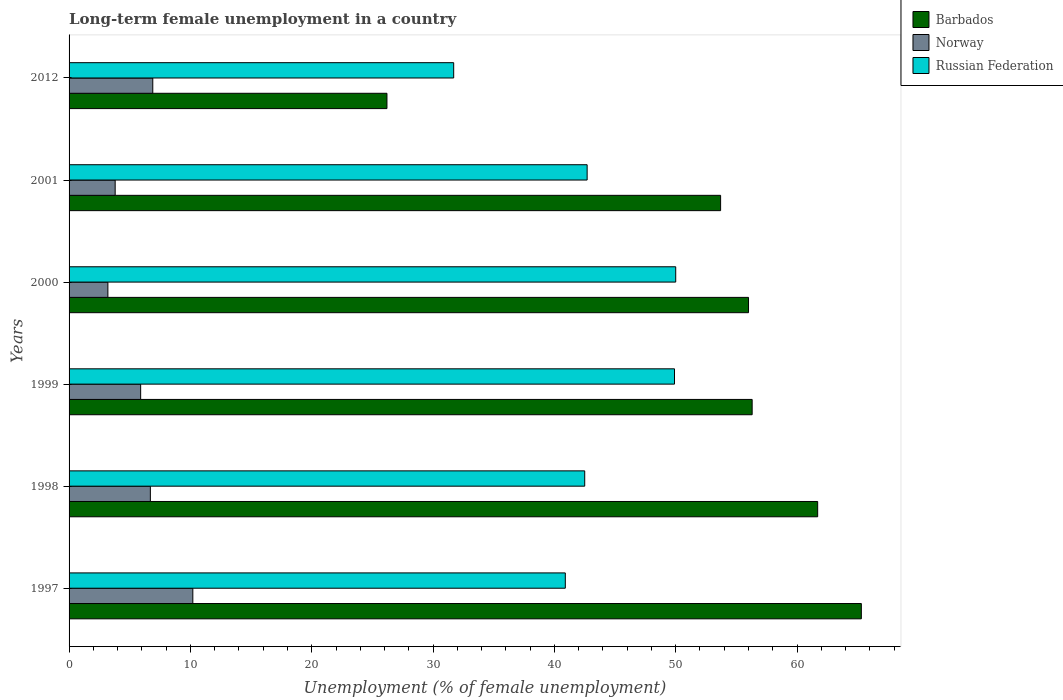How many groups of bars are there?
Provide a short and direct response. 6. How many bars are there on the 3rd tick from the top?
Offer a terse response. 3. In how many cases, is the number of bars for a given year not equal to the number of legend labels?
Provide a succinct answer. 0. Across all years, what is the maximum percentage of long-term unemployed female population in Russian Federation?
Your answer should be compact. 50. Across all years, what is the minimum percentage of long-term unemployed female population in Norway?
Ensure brevity in your answer.  3.2. What is the total percentage of long-term unemployed female population in Russian Federation in the graph?
Provide a succinct answer. 257.7. What is the difference between the percentage of long-term unemployed female population in Norway in 1998 and that in 2001?
Offer a very short reply. 2.9. What is the difference between the percentage of long-term unemployed female population in Russian Federation in 2000 and the percentage of long-term unemployed female population in Barbados in 1998?
Ensure brevity in your answer.  -11.7. What is the average percentage of long-term unemployed female population in Russian Federation per year?
Your answer should be very brief. 42.95. In the year 1997, what is the difference between the percentage of long-term unemployed female population in Barbados and percentage of long-term unemployed female population in Norway?
Ensure brevity in your answer.  55.1. In how many years, is the percentage of long-term unemployed female population in Barbados greater than 58 %?
Ensure brevity in your answer.  2. What is the ratio of the percentage of long-term unemployed female population in Barbados in 1999 to that in 2012?
Make the answer very short. 2.15. What is the difference between the highest and the second highest percentage of long-term unemployed female population in Norway?
Offer a very short reply. 3.3. What is the difference between the highest and the lowest percentage of long-term unemployed female population in Norway?
Your response must be concise. 7. In how many years, is the percentage of long-term unemployed female population in Norway greater than the average percentage of long-term unemployed female population in Norway taken over all years?
Your response must be concise. 3. What does the 2nd bar from the top in 2012 represents?
Give a very brief answer. Norway. Is it the case that in every year, the sum of the percentage of long-term unemployed female population in Russian Federation and percentage of long-term unemployed female population in Barbados is greater than the percentage of long-term unemployed female population in Norway?
Your answer should be compact. Yes. Are all the bars in the graph horizontal?
Provide a short and direct response. Yes. Does the graph contain any zero values?
Your answer should be very brief. No. Where does the legend appear in the graph?
Your answer should be compact. Top right. How many legend labels are there?
Offer a very short reply. 3. How are the legend labels stacked?
Your answer should be very brief. Vertical. What is the title of the graph?
Your response must be concise. Long-term female unemployment in a country. What is the label or title of the X-axis?
Provide a short and direct response. Unemployment (% of female unemployment). What is the Unemployment (% of female unemployment) in Barbados in 1997?
Offer a very short reply. 65.3. What is the Unemployment (% of female unemployment) in Norway in 1997?
Your response must be concise. 10.2. What is the Unemployment (% of female unemployment) of Russian Federation in 1997?
Your answer should be compact. 40.9. What is the Unemployment (% of female unemployment) of Barbados in 1998?
Give a very brief answer. 61.7. What is the Unemployment (% of female unemployment) of Norway in 1998?
Offer a terse response. 6.7. What is the Unemployment (% of female unemployment) in Russian Federation in 1998?
Offer a terse response. 42.5. What is the Unemployment (% of female unemployment) of Barbados in 1999?
Your answer should be very brief. 56.3. What is the Unemployment (% of female unemployment) in Norway in 1999?
Provide a succinct answer. 5.9. What is the Unemployment (% of female unemployment) in Russian Federation in 1999?
Give a very brief answer. 49.9. What is the Unemployment (% of female unemployment) of Barbados in 2000?
Offer a very short reply. 56. What is the Unemployment (% of female unemployment) in Norway in 2000?
Your answer should be very brief. 3.2. What is the Unemployment (% of female unemployment) of Russian Federation in 2000?
Give a very brief answer. 50. What is the Unemployment (% of female unemployment) in Barbados in 2001?
Offer a very short reply. 53.7. What is the Unemployment (% of female unemployment) of Norway in 2001?
Your answer should be compact. 3.8. What is the Unemployment (% of female unemployment) in Russian Federation in 2001?
Keep it short and to the point. 42.7. What is the Unemployment (% of female unemployment) of Barbados in 2012?
Your response must be concise. 26.2. What is the Unemployment (% of female unemployment) of Norway in 2012?
Keep it short and to the point. 6.9. What is the Unemployment (% of female unemployment) of Russian Federation in 2012?
Offer a terse response. 31.7. Across all years, what is the maximum Unemployment (% of female unemployment) of Barbados?
Keep it short and to the point. 65.3. Across all years, what is the maximum Unemployment (% of female unemployment) of Norway?
Make the answer very short. 10.2. Across all years, what is the maximum Unemployment (% of female unemployment) of Russian Federation?
Make the answer very short. 50. Across all years, what is the minimum Unemployment (% of female unemployment) of Barbados?
Provide a short and direct response. 26.2. Across all years, what is the minimum Unemployment (% of female unemployment) in Norway?
Your answer should be compact. 3.2. Across all years, what is the minimum Unemployment (% of female unemployment) of Russian Federation?
Give a very brief answer. 31.7. What is the total Unemployment (% of female unemployment) of Barbados in the graph?
Ensure brevity in your answer.  319.2. What is the total Unemployment (% of female unemployment) in Norway in the graph?
Give a very brief answer. 36.7. What is the total Unemployment (% of female unemployment) in Russian Federation in the graph?
Offer a very short reply. 257.7. What is the difference between the Unemployment (% of female unemployment) of Norway in 1997 and that in 1998?
Provide a short and direct response. 3.5. What is the difference between the Unemployment (% of female unemployment) of Russian Federation in 1997 and that in 1998?
Your answer should be compact. -1.6. What is the difference between the Unemployment (% of female unemployment) of Norway in 1997 and that in 1999?
Offer a very short reply. 4.3. What is the difference between the Unemployment (% of female unemployment) of Barbados in 1997 and that in 2000?
Offer a terse response. 9.3. What is the difference between the Unemployment (% of female unemployment) of Norway in 1997 and that in 2000?
Your answer should be compact. 7. What is the difference between the Unemployment (% of female unemployment) of Russian Federation in 1997 and that in 2001?
Offer a very short reply. -1.8. What is the difference between the Unemployment (% of female unemployment) in Barbados in 1997 and that in 2012?
Ensure brevity in your answer.  39.1. What is the difference between the Unemployment (% of female unemployment) in Russian Federation in 1997 and that in 2012?
Your answer should be very brief. 9.2. What is the difference between the Unemployment (% of female unemployment) of Barbados in 1998 and that in 1999?
Provide a short and direct response. 5.4. What is the difference between the Unemployment (% of female unemployment) in Russian Federation in 1998 and that in 1999?
Your response must be concise. -7.4. What is the difference between the Unemployment (% of female unemployment) of Barbados in 1998 and that in 2000?
Your answer should be very brief. 5.7. What is the difference between the Unemployment (% of female unemployment) of Barbados in 1998 and that in 2012?
Your answer should be very brief. 35.5. What is the difference between the Unemployment (% of female unemployment) in Norway in 1999 and that in 2000?
Make the answer very short. 2.7. What is the difference between the Unemployment (% of female unemployment) of Russian Federation in 1999 and that in 2000?
Give a very brief answer. -0.1. What is the difference between the Unemployment (% of female unemployment) in Norway in 1999 and that in 2001?
Your answer should be very brief. 2.1. What is the difference between the Unemployment (% of female unemployment) of Russian Federation in 1999 and that in 2001?
Provide a short and direct response. 7.2. What is the difference between the Unemployment (% of female unemployment) of Barbados in 1999 and that in 2012?
Offer a terse response. 30.1. What is the difference between the Unemployment (% of female unemployment) of Norway in 1999 and that in 2012?
Keep it short and to the point. -1. What is the difference between the Unemployment (% of female unemployment) of Russian Federation in 1999 and that in 2012?
Offer a terse response. 18.2. What is the difference between the Unemployment (% of female unemployment) of Russian Federation in 2000 and that in 2001?
Your answer should be compact. 7.3. What is the difference between the Unemployment (% of female unemployment) in Barbados in 2000 and that in 2012?
Provide a succinct answer. 29.8. What is the difference between the Unemployment (% of female unemployment) of Norway in 2000 and that in 2012?
Your answer should be very brief. -3.7. What is the difference between the Unemployment (% of female unemployment) of Russian Federation in 2000 and that in 2012?
Offer a terse response. 18.3. What is the difference between the Unemployment (% of female unemployment) of Barbados in 1997 and the Unemployment (% of female unemployment) of Norway in 1998?
Provide a short and direct response. 58.6. What is the difference between the Unemployment (% of female unemployment) of Barbados in 1997 and the Unemployment (% of female unemployment) of Russian Federation in 1998?
Keep it short and to the point. 22.8. What is the difference between the Unemployment (% of female unemployment) of Norway in 1997 and the Unemployment (% of female unemployment) of Russian Federation in 1998?
Your response must be concise. -32.3. What is the difference between the Unemployment (% of female unemployment) of Barbados in 1997 and the Unemployment (% of female unemployment) of Norway in 1999?
Make the answer very short. 59.4. What is the difference between the Unemployment (% of female unemployment) of Barbados in 1997 and the Unemployment (% of female unemployment) of Russian Federation in 1999?
Your answer should be very brief. 15.4. What is the difference between the Unemployment (% of female unemployment) in Norway in 1997 and the Unemployment (% of female unemployment) in Russian Federation in 1999?
Give a very brief answer. -39.7. What is the difference between the Unemployment (% of female unemployment) of Barbados in 1997 and the Unemployment (% of female unemployment) of Norway in 2000?
Offer a very short reply. 62.1. What is the difference between the Unemployment (% of female unemployment) in Barbados in 1997 and the Unemployment (% of female unemployment) in Russian Federation in 2000?
Make the answer very short. 15.3. What is the difference between the Unemployment (% of female unemployment) of Norway in 1997 and the Unemployment (% of female unemployment) of Russian Federation in 2000?
Keep it short and to the point. -39.8. What is the difference between the Unemployment (% of female unemployment) of Barbados in 1997 and the Unemployment (% of female unemployment) of Norway in 2001?
Give a very brief answer. 61.5. What is the difference between the Unemployment (% of female unemployment) of Barbados in 1997 and the Unemployment (% of female unemployment) of Russian Federation in 2001?
Offer a terse response. 22.6. What is the difference between the Unemployment (% of female unemployment) of Norway in 1997 and the Unemployment (% of female unemployment) of Russian Federation in 2001?
Give a very brief answer. -32.5. What is the difference between the Unemployment (% of female unemployment) of Barbados in 1997 and the Unemployment (% of female unemployment) of Norway in 2012?
Provide a short and direct response. 58.4. What is the difference between the Unemployment (% of female unemployment) of Barbados in 1997 and the Unemployment (% of female unemployment) of Russian Federation in 2012?
Offer a terse response. 33.6. What is the difference between the Unemployment (% of female unemployment) of Norway in 1997 and the Unemployment (% of female unemployment) of Russian Federation in 2012?
Your answer should be very brief. -21.5. What is the difference between the Unemployment (% of female unemployment) of Barbados in 1998 and the Unemployment (% of female unemployment) of Norway in 1999?
Offer a terse response. 55.8. What is the difference between the Unemployment (% of female unemployment) in Norway in 1998 and the Unemployment (% of female unemployment) in Russian Federation in 1999?
Keep it short and to the point. -43.2. What is the difference between the Unemployment (% of female unemployment) in Barbados in 1998 and the Unemployment (% of female unemployment) in Norway in 2000?
Your response must be concise. 58.5. What is the difference between the Unemployment (% of female unemployment) in Norway in 1998 and the Unemployment (% of female unemployment) in Russian Federation in 2000?
Make the answer very short. -43.3. What is the difference between the Unemployment (% of female unemployment) in Barbados in 1998 and the Unemployment (% of female unemployment) in Norway in 2001?
Your answer should be very brief. 57.9. What is the difference between the Unemployment (% of female unemployment) of Norway in 1998 and the Unemployment (% of female unemployment) of Russian Federation in 2001?
Your answer should be very brief. -36. What is the difference between the Unemployment (% of female unemployment) of Barbados in 1998 and the Unemployment (% of female unemployment) of Norway in 2012?
Give a very brief answer. 54.8. What is the difference between the Unemployment (% of female unemployment) of Norway in 1998 and the Unemployment (% of female unemployment) of Russian Federation in 2012?
Provide a short and direct response. -25. What is the difference between the Unemployment (% of female unemployment) of Barbados in 1999 and the Unemployment (% of female unemployment) of Norway in 2000?
Your response must be concise. 53.1. What is the difference between the Unemployment (% of female unemployment) in Norway in 1999 and the Unemployment (% of female unemployment) in Russian Federation in 2000?
Make the answer very short. -44.1. What is the difference between the Unemployment (% of female unemployment) in Barbados in 1999 and the Unemployment (% of female unemployment) in Norway in 2001?
Offer a very short reply. 52.5. What is the difference between the Unemployment (% of female unemployment) of Norway in 1999 and the Unemployment (% of female unemployment) of Russian Federation in 2001?
Make the answer very short. -36.8. What is the difference between the Unemployment (% of female unemployment) of Barbados in 1999 and the Unemployment (% of female unemployment) of Norway in 2012?
Your answer should be compact. 49.4. What is the difference between the Unemployment (% of female unemployment) in Barbados in 1999 and the Unemployment (% of female unemployment) in Russian Federation in 2012?
Offer a terse response. 24.6. What is the difference between the Unemployment (% of female unemployment) in Norway in 1999 and the Unemployment (% of female unemployment) in Russian Federation in 2012?
Offer a very short reply. -25.8. What is the difference between the Unemployment (% of female unemployment) of Barbados in 2000 and the Unemployment (% of female unemployment) of Norway in 2001?
Your response must be concise. 52.2. What is the difference between the Unemployment (% of female unemployment) of Norway in 2000 and the Unemployment (% of female unemployment) of Russian Federation in 2001?
Keep it short and to the point. -39.5. What is the difference between the Unemployment (% of female unemployment) in Barbados in 2000 and the Unemployment (% of female unemployment) in Norway in 2012?
Provide a succinct answer. 49.1. What is the difference between the Unemployment (% of female unemployment) of Barbados in 2000 and the Unemployment (% of female unemployment) of Russian Federation in 2012?
Make the answer very short. 24.3. What is the difference between the Unemployment (% of female unemployment) in Norway in 2000 and the Unemployment (% of female unemployment) in Russian Federation in 2012?
Your response must be concise. -28.5. What is the difference between the Unemployment (% of female unemployment) of Barbados in 2001 and the Unemployment (% of female unemployment) of Norway in 2012?
Make the answer very short. 46.8. What is the difference between the Unemployment (% of female unemployment) of Norway in 2001 and the Unemployment (% of female unemployment) of Russian Federation in 2012?
Your answer should be compact. -27.9. What is the average Unemployment (% of female unemployment) of Barbados per year?
Your answer should be compact. 53.2. What is the average Unemployment (% of female unemployment) in Norway per year?
Ensure brevity in your answer.  6.12. What is the average Unemployment (% of female unemployment) in Russian Federation per year?
Your response must be concise. 42.95. In the year 1997, what is the difference between the Unemployment (% of female unemployment) in Barbados and Unemployment (% of female unemployment) in Norway?
Offer a terse response. 55.1. In the year 1997, what is the difference between the Unemployment (% of female unemployment) of Barbados and Unemployment (% of female unemployment) of Russian Federation?
Offer a very short reply. 24.4. In the year 1997, what is the difference between the Unemployment (% of female unemployment) in Norway and Unemployment (% of female unemployment) in Russian Federation?
Your answer should be compact. -30.7. In the year 1998, what is the difference between the Unemployment (% of female unemployment) of Barbados and Unemployment (% of female unemployment) of Norway?
Provide a succinct answer. 55. In the year 1998, what is the difference between the Unemployment (% of female unemployment) of Norway and Unemployment (% of female unemployment) of Russian Federation?
Provide a short and direct response. -35.8. In the year 1999, what is the difference between the Unemployment (% of female unemployment) of Barbados and Unemployment (% of female unemployment) of Norway?
Your answer should be very brief. 50.4. In the year 1999, what is the difference between the Unemployment (% of female unemployment) of Barbados and Unemployment (% of female unemployment) of Russian Federation?
Provide a short and direct response. 6.4. In the year 1999, what is the difference between the Unemployment (% of female unemployment) in Norway and Unemployment (% of female unemployment) in Russian Federation?
Your answer should be very brief. -44. In the year 2000, what is the difference between the Unemployment (% of female unemployment) of Barbados and Unemployment (% of female unemployment) of Norway?
Keep it short and to the point. 52.8. In the year 2000, what is the difference between the Unemployment (% of female unemployment) of Norway and Unemployment (% of female unemployment) of Russian Federation?
Ensure brevity in your answer.  -46.8. In the year 2001, what is the difference between the Unemployment (% of female unemployment) of Barbados and Unemployment (% of female unemployment) of Norway?
Offer a very short reply. 49.9. In the year 2001, what is the difference between the Unemployment (% of female unemployment) of Barbados and Unemployment (% of female unemployment) of Russian Federation?
Provide a succinct answer. 11. In the year 2001, what is the difference between the Unemployment (% of female unemployment) in Norway and Unemployment (% of female unemployment) in Russian Federation?
Give a very brief answer. -38.9. In the year 2012, what is the difference between the Unemployment (% of female unemployment) of Barbados and Unemployment (% of female unemployment) of Norway?
Your response must be concise. 19.3. In the year 2012, what is the difference between the Unemployment (% of female unemployment) in Norway and Unemployment (% of female unemployment) in Russian Federation?
Provide a short and direct response. -24.8. What is the ratio of the Unemployment (% of female unemployment) of Barbados in 1997 to that in 1998?
Your response must be concise. 1.06. What is the ratio of the Unemployment (% of female unemployment) in Norway in 1997 to that in 1998?
Your response must be concise. 1.52. What is the ratio of the Unemployment (% of female unemployment) of Russian Federation in 1997 to that in 1998?
Your answer should be compact. 0.96. What is the ratio of the Unemployment (% of female unemployment) of Barbados in 1997 to that in 1999?
Give a very brief answer. 1.16. What is the ratio of the Unemployment (% of female unemployment) in Norway in 1997 to that in 1999?
Your answer should be compact. 1.73. What is the ratio of the Unemployment (% of female unemployment) in Russian Federation in 1997 to that in 1999?
Your answer should be compact. 0.82. What is the ratio of the Unemployment (% of female unemployment) of Barbados in 1997 to that in 2000?
Give a very brief answer. 1.17. What is the ratio of the Unemployment (% of female unemployment) of Norway in 1997 to that in 2000?
Provide a succinct answer. 3.19. What is the ratio of the Unemployment (% of female unemployment) in Russian Federation in 1997 to that in 2000?
Offer a very short reply. 0.82. What is the ratio of the Unemployment (% of female unemployment) of Barbados in 1997 to that in 2001?
Offer a very short reply. 1.22. What is the ratio of the Unemployment (% of female unemployment) in Norway in 1997 to that in 2001?
Make the answer very short. 2.68. What is the ratio of the Unemployment (% of female unemployment) of Russian Federation in 1997 to that in 2001?
Give a very brief answer. 0.96. What is the ratio of the Unemployment (% of female unemployment) in Barbados in 1997 to that in 2012?
Offer a terse response. 2.49. What is the ratio of the Unemployment (% of female unemployment) of Norway in 1997 to that in 2012?
Ensure brevity in your answer.  1.48. What is the ratio of the Unemployment (% of female unemployment) of Russian Federation in 1997 to that in 2012?
Ensure brevity in your answer.  1.29. What is the ratio of the Unemployment (% of female unemployment) in Barbados in 1998 to that in 1999?
Offer a terse response. 1.1. What is the ratio of the Unemployment (% of female unemployment) of Norway in 1998 to that in 1999?
Ensure brevity in your answer.  1.14. What is the ratio of the Unemployment (% of female unemployment) of Russian Federation in 1998 to that in 1999?
Make the answer very short. 0.85. What is the ratio of the Unemployment (% of female unemployment) in Barbados in 1998 to that in 2000?
Your answer should be very brief. 1.1. What is the ratio of the Unemployment (% of female unemployment) of Norway in 1998 to that in 2000?
Your answer should be very brief. 2.09. What is the ratio of the Unemployment (% of female unemployment) in Russian Federation in 1998 to that in 2000?
Your response must be concise. 0.85. What is the ratio of the Unemployment (% of female unemployment) of Barbados in 1998 to that in 2001?
Your answer should be compact. 1.15. What is the ratio of the Unemployment (% of female unemployment) of Norway in 1998 to that in 2001?
Offer a very short reply. 1.76. What is the ratio of the Unemployment (% of female unemployment) in Russian Federation in 1998 to that in 2001?
Offer a terse response. 1. What is the ratio of the Unemployment (% of female unemployment) in Barbados in 1998 to that in 2012?
Your answer should be very brief. 2.35. What is the ratio of the Unemployment (% of female unemployment) in Russian Federation in 1998 to that in 2012?
Offer a terse response. 1.34. What is the ratio of the Unemployment (% of female unemployment) of Barbados in 1999 to that in 2000?
Your response must be concise. 1.01. What is the ratio of the Unemployment (% of female unemployment) in Norway in 1999 to that in 2000?
Offer a terse response. 1.84. What is the ratio of the Unemployment (% of female unemployment) of Russian Federation in 1999 to that in 2000?
Your answer should be compact. 1. What is the ratio of the Unemployment (% of female unemployment) in Barbados in 1999 to that in 2001?
Offer a very short reply. 1.05. What is the ratio of the Unemployment (% of female unemployment) of Norway in 1999 to that in 2001?
Your response must be concise. 1.55. What is the ratio of the Unemployment (% of female unemployment) of Russian Federation in 1999 to that in 2001?
Your answer should be compact. 1.17. What is the ratio of the Unemployment (% of female unemployment) of Barbados in 1999 to that in 2012?
Your response must be concise. 2.15. What is the ratio of the Unemployment (% of female unemployment) of Norway in 1999 to that in 2012?
Ensure brevity in your answer.  0.86. What is the ratio of the Unemployment (% of female unemployment) in Russian Federation in 1999 to that in 2012?
Your answer should be very brief. 1.57. What is the ratio of the Unemployment (% of female unemployment) in Barbados in 2000 to that in 2001?
Your answer should be compact. 1.04. What is the ratio of the Unemployment (% of female unemployment) of Norway in 2000 to that in 2001?
Make the answer very short. 0.84. What is the ratio of the Unemployment (% of female unemployment) in Russian Federation in 2000 to that in 2001?
Give a very brief answer. 1.17. What is the ratio of the Unemployment (% of female unemployment) of Barbados in 2000 to that in 2012?
Offer a terse response. 2.14. What is the ratio of the Unemployment (% of female unemployment) in Norway in 2000 to that in 2012?
Offer a terse response. 0.46. What is the ratio of the Unemployment (% of female unemployment) of Russian Federation in 2000 to that in 2012?
Offer a very short reply. 1.58. What is the ratio of the Unemployment (% of female unemployment) of Barbados in 2001 to that in 2012?
Give a very brief answer. 2.05. What is the ratio of the Unemployment (% of female unemployment) in Norway in 2001 to that in 2012?
Provide a succinct answer. 0.55. What is the ratio of the Unemployment (% of female unemployment) in Russian Federation in 2001 to that in 2012?
Keep it short and to the point. 1.35. What is the difference between the highest and the second highest Unemployment (% of female unemployment) in Russian Federation?
Offer a very short reply. 0.1. What is the difference between the highest and the lowest Unemployment (% of female unemployment) in Barbados?
Provide a succinct answer. 39.1. What is the difference between the highest and the lowest Unemployment (% of female unemployment) of Norway?
Give a very brief answer. 7. 